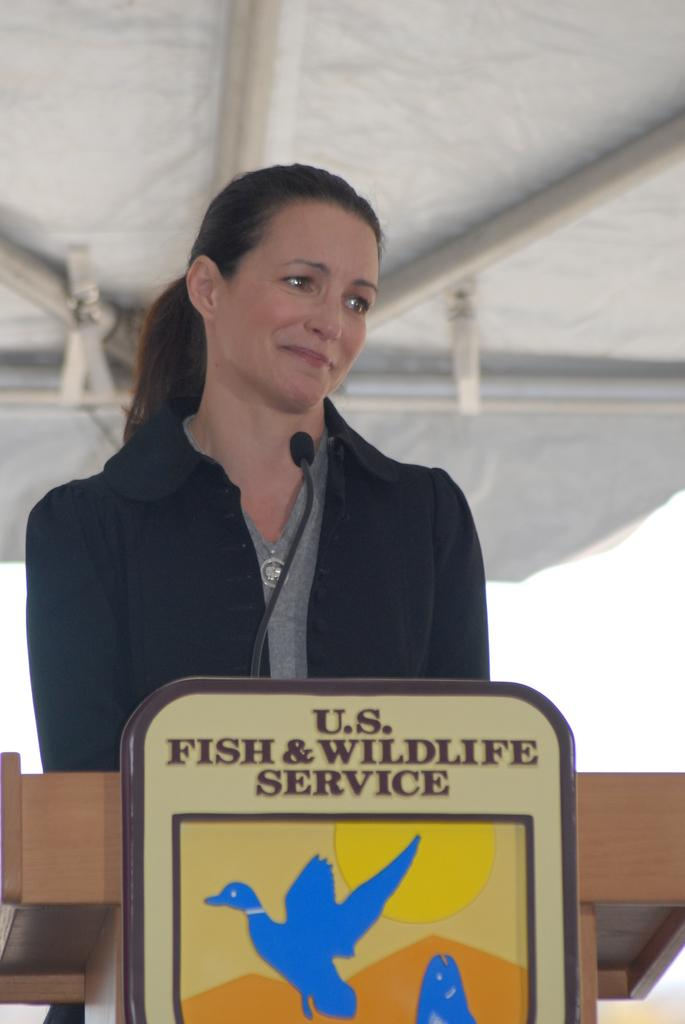<image>
Summarize the visual content of the image. A female stands behind a US Fish and Wildlife podium 